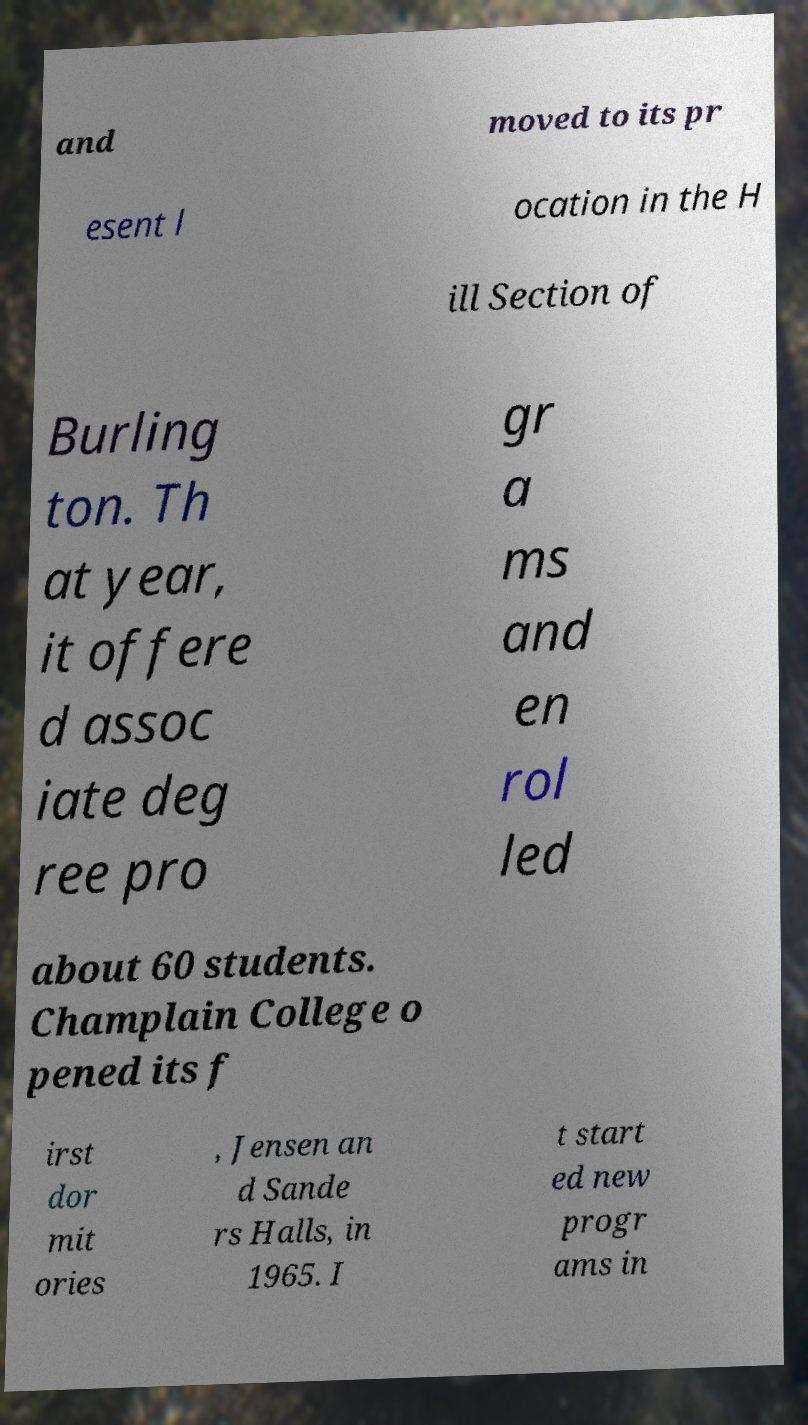I need the written content from this picture converted into text. Can you do that? and moved to its pr esent l ocation in the H ill Section of Burling ton. Th at year, it offere d assoc iate deg ree pro gr a ms and en rol led about 60 students. Champlain College o pened its f irst dor mit ories , Jensen an d Sande rs Halls, in 1965. I t start ed new progr ams in 